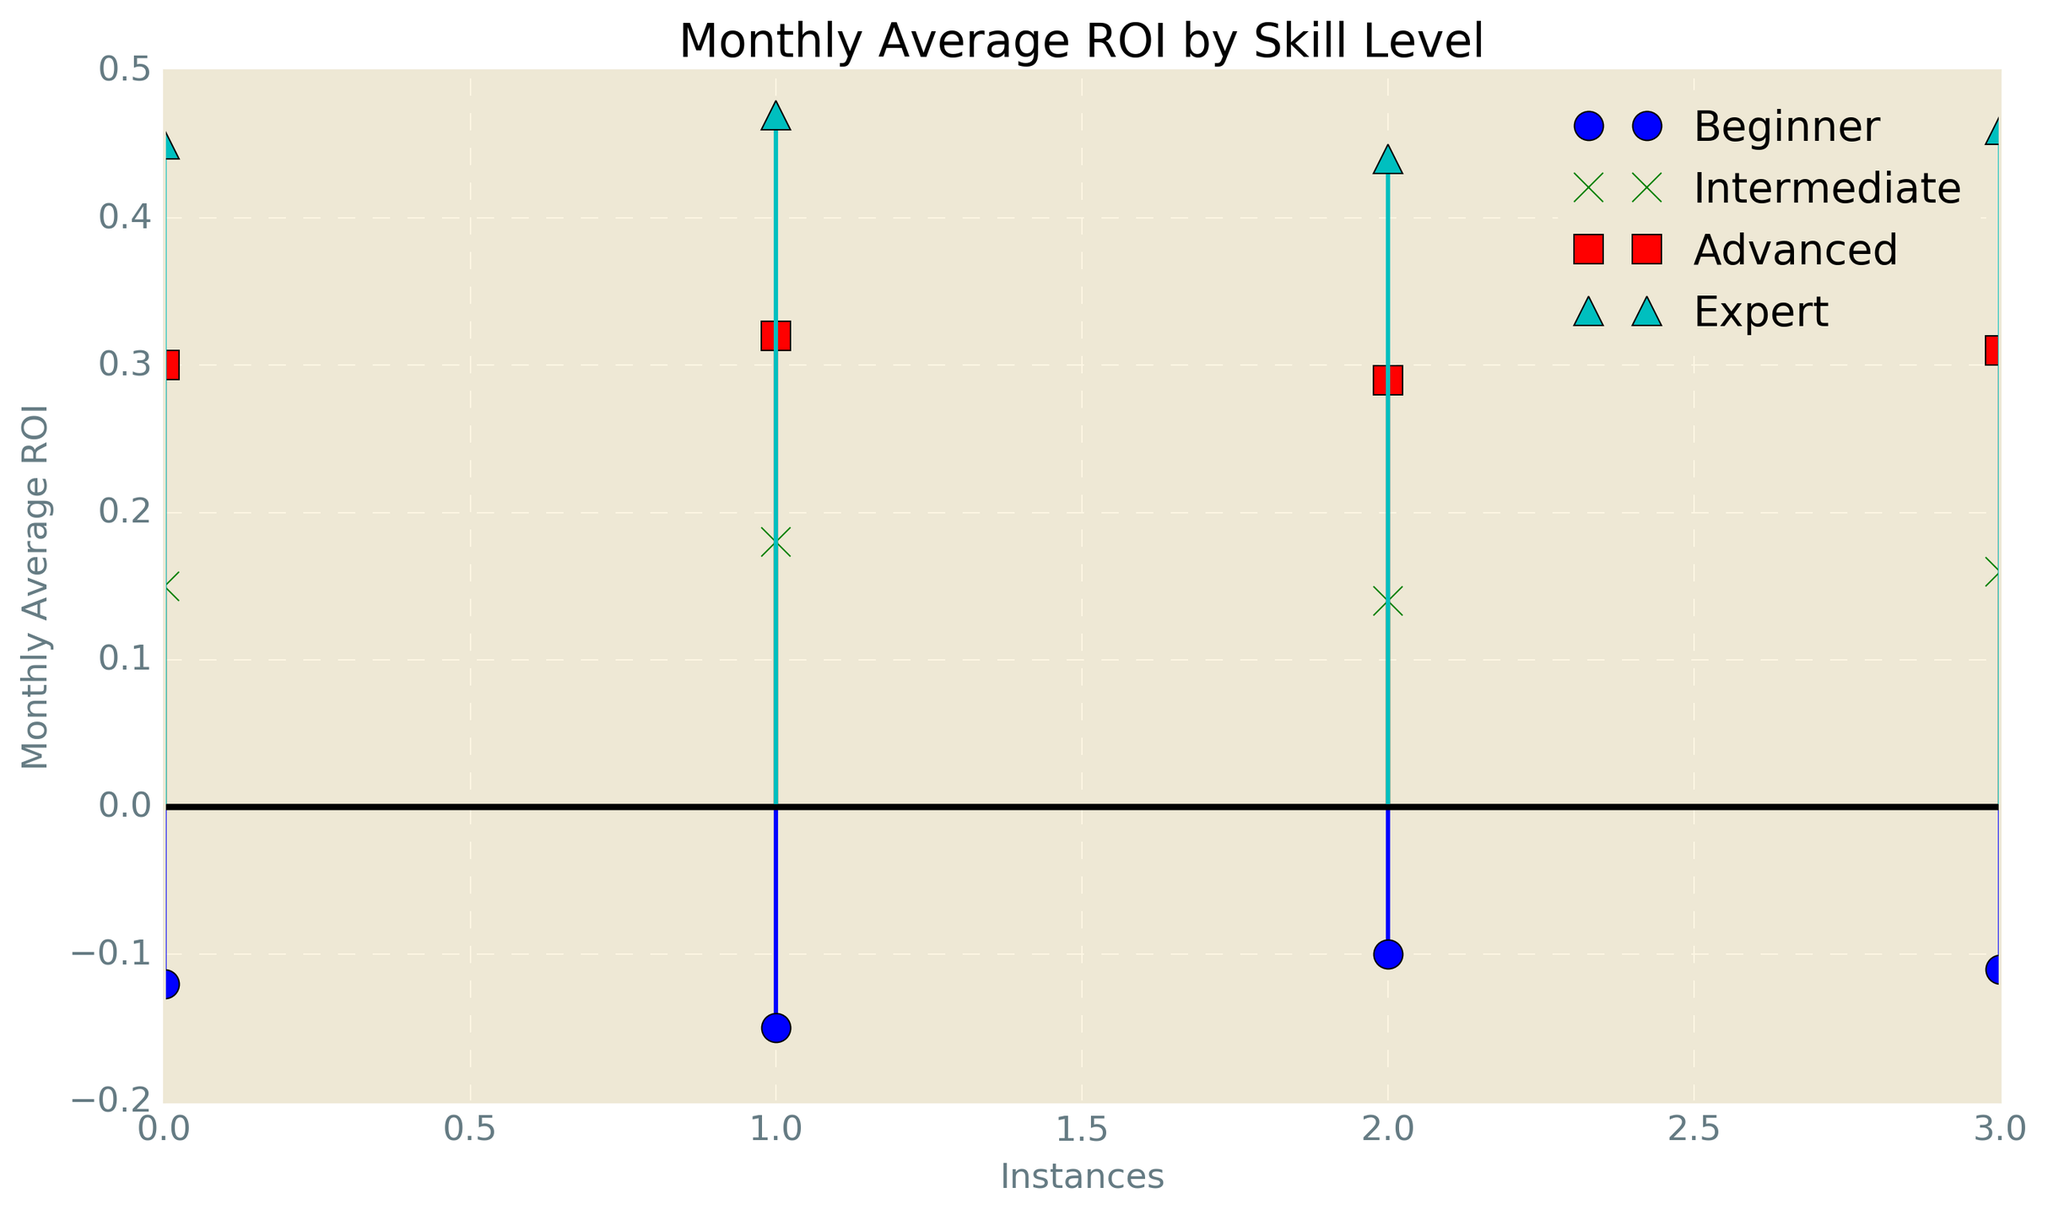What is the pattern of Monthly Average ROI for Beginners? The pattern shows all data points of Beginners are below zero, indicating a negative ROI for all instances of this group.
Answer: Negative ROI Which skill level group displays the highest average ROI? Expert displays the highest individual monthly average ROIs, typically around 0.45 to 0.47, which is higher than the values for any other group.
Answer: Expert How does the overall trend in ROI change as skill level increases from Beginner to Expert? As skill level increases from Beginner to Expert, the Monthly Average ROI increases from negative values for Beginners to progressively higher positive values, with Experts showing the highest ROI.
Answer: Increases Compare the ROIs of Intermediate and Advanced skill levels. Which group has higher values? The Intermediate group has ROIs around 0.14 to 0.18, whereas the Advanced group has higher ROIs around 0.29 to 0.32.
Answer: Advanced What's the difference between the highest Monthly Average ROI for Beginners and the lowest Monthly Average ROI for Experts? The highest ROI for Beginners is -0.10, while the lowest ROI for Experts is 0.44. The difference is 0.44 - (-0.10) = 0.54.
Answer: 0.54 What is the color used to represent the Intermediate skill level's data points in the plot? The Intermediate skill level's data points are represented in green.
Answer: Green Is there any overlapping in the ROI values of the Intermediate and Advanced skill levels? No, there is no overlapping; the Intermediate group's highest ROI is 0.18, while the Advanced group's lowest ROI is 0.29.
Answer: No How many distinct ROI values are there for the Expert group? There are four distinct ROI values for the Expert group: 0.45, 0.47, 0.44, and 0.46.
Answer: 4 What visual marker shape is used for the Advanced skill level in the plot? The Advanced skill level uses a square (s) marker shape.
Answer: Square What is the range of Monthly Average ROI for the Intermediate group? The lowest ROI is 0.14 and the highest is 0.18, giving a range of 0.18 - 0.14 = 0.04.
Answer: 0.04 